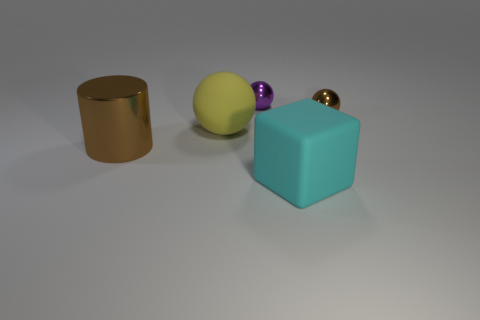Does the tiny object on the right side of the rubber cube have the same color as the metallic cylinder?
Give a very brief answer. Yes. What number of large cyan things have the same material as the purple thing?
Offer a very short reply. 0. There is another metallic object that is the same shape as the tiny brown metallic thing; what is its size?
Offer a very short reply. Small. There is a brown thing that is on the left side of the matte block; is its shape the same as the tiny brown metallic object?
Make the answer very short. No. There is a metal object that is in front of the large object that is behind the shiny cylinder; what is its shape?
Your answer should be compact. Cylinder. Are there any other things that have the same shape as the big yellow rubber thing?
Make the answer very short. Yes. What is the color of the other tiny shiny thing that is the same shape as the tiny purple metal thing?
Your answer should be very brief. Brown. Is the color of the matte ball the same as the big cylinder left of the tiny brown metal object?
Ensure brevity in your answer.  No. There is a thing that is both on the right side of the large yellow rubber object and on the left side of the large cyan cube; what is its shape?
Offer a terse response. Sphere. Are there fewer cyan rubber blocks than tiny red shiny cubes?
Provide a short and direct response. No. 